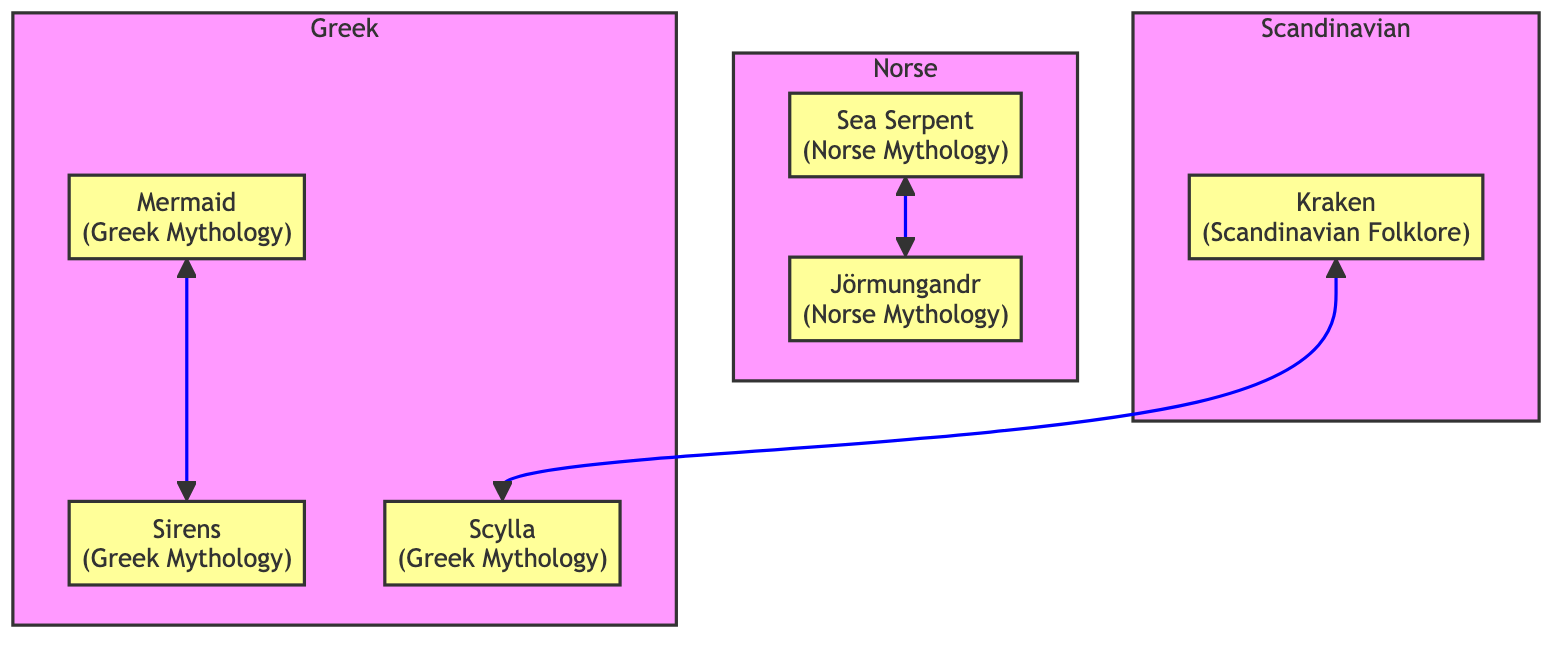What's the origin of the Mermaid? The Mermaid is linked to Greek Mythology as indicated in the diagram. It shows "Greek Mythology" as the label connected with the Mermaid node.
Answer: Greek Mythology How many creatures are related to Sirens? The Sirens are directly related to one creature, the Mermaid, as shown by the connection in the diagram.
Answer: 1 What is Scylla's primary attribute? The diagram lists "Multiple heads" as one of Scylla's attributes, which is directly labeled in the node connected to Scylla.
Answer: Multiple heads Which two mythical creatures belong to Norse mythology? The diagram shows Sea Serpent and Jörmungandr as belonging to Norse Mythology, indicated within the subgraph labeled Norse.
Answer: Sea Serpent and Jörmungandr Which creature is associated with both Greek and Scandinavian mythology? The diagram illustrates a connection between Scylla (Greek Mythology) and Kraken (Scandinavian Folklore) through their respective relationships with other creatures. However, since there are no direct relations indicated for both, the answer is not straightforward; but considering the attributes, it highlights an indirect association through their mutual anecdotal roles in maritime tales.
Answer: None What connects the Kraken and Scylla? The diagram shows a direct relationship between Kraken and Scylla through the connecting line, indicating they are related in the mythological family tree.
Answer: Scylla How does Jörmungandr relate to the Sea Serpent? The diagram specifies a direct relationship between Jörmungandr and Sea Serpent, shown by the connecting line. Jörmungandr is essentially a representation of the Sea Serpent in Norse mythology.
Answer: Sea Serpent What feature is unique to Sirens compared to Mermaids? The diagram notes that Sirens have a "Luring voice" which is a unique attribute distinguishing them from Mermaids' attributes. While they share similarities, this feature is specifically associated with Sirens.
Answer: Luring voice How many connections does Kraken have? The diagram reveals that the Kraken is connected to one other creature, which is Scylla, making its total connections equal to one.
Answer: 1 